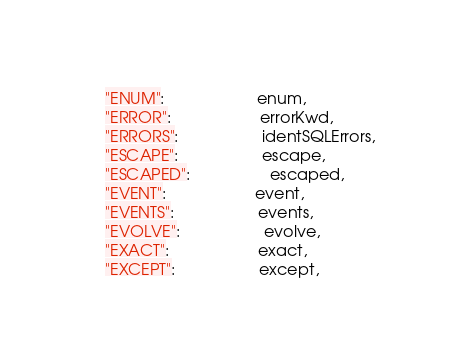<code> <loc_0><loc_0><loc_500><loc_500><_Go_>	"ENUM":                     enum,
	"ERROR":                    errorKwd,
	"ERRORS":                   identSQLErrors,
	"ESCAPE":                   escape,
	"ESCAPED":                  escaped,
	"EVENT":                    event,
	"EVENTS":                   events,
	"EVOLVE":                   evolve,
	"EXACT":                    exact,
	"EXCEPT":                   except,</code> 